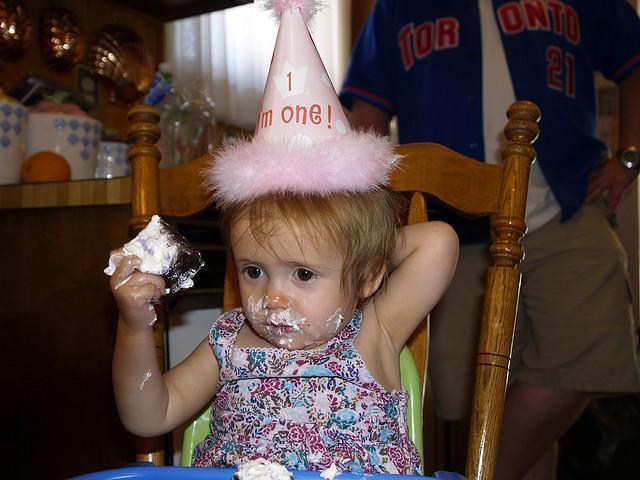How many people can you see?
Give a very brief answer. 2. 